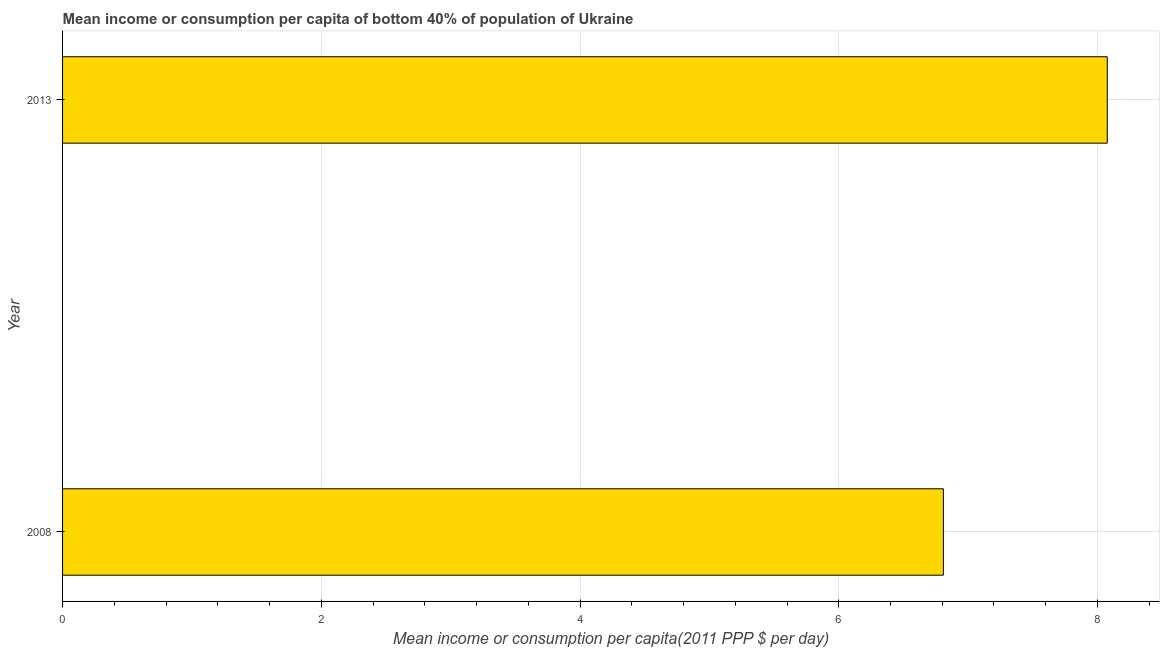Does the graph contain any zero values?
Offer a terse response. No. Does the graph contain grids?
Ensure brevity in your answer.  Yes. What is the title of the graph?
Make the answer very short. Mean income or consumption per capita of bottom 40% of population of Ukraine. What is the label or title of the X-axis?
Offer a very short reply. Mean income or consumption per capita(2011 PPP $ per day). What is the label or title of the Y-axis?
Your response must be concise. Year. What is the mean income or consumption in 2013?
Keep it short and to the point. 8.08. Across all years, what is the maximum mean income or consumption?
Offer a terse response. 8.08. Across all years, what is the minimum mean income or consumption?
Ensure brevity in your answer.  6.81. What is the sum of the mean income or consumption?
Your answer should be very brief. 14.88. What is the difference between the mean income or consumption in 2008 and 2013?
Your response must be concise. -1.27. What is the average mean income or consumption per year?
Your answer should be compact. 7.44. What is the median mean income or consumption?
Offer a very short reply. 7.44. Do a majority of the years between 2008 and 2013 (inclusive) have mean income or consumption greater than 3.6 $?
Your answer should be very brief. Yes. What is the ratio of the mean income or consumption in 2008 to that in 2013?
Give a very brief answer. 0.84. How many bars are there?
Make the answer very short. 2. Are all the bars in the graph horizontal?
Give a very brief answer. Yes. What is the Mean income or consumption per capita(2011 PPP $ per day) in 2008?
Offer a very short reply. 6.81. What is the Mean income or consumption per capita(2011 PPP $ per day) of 2013?
Your response must be concise. 8.08. What is the difference between the Mean income or consumption per capita(2011 PPP $ per day) in 2008 and 2013?
Your answer should be very brief. -1.27. What is the ratio of the Mean income or consumption per capita(2011 PPP $ per day) in 2008 to that in 2013?
Give a very brief answer. 0.84. 